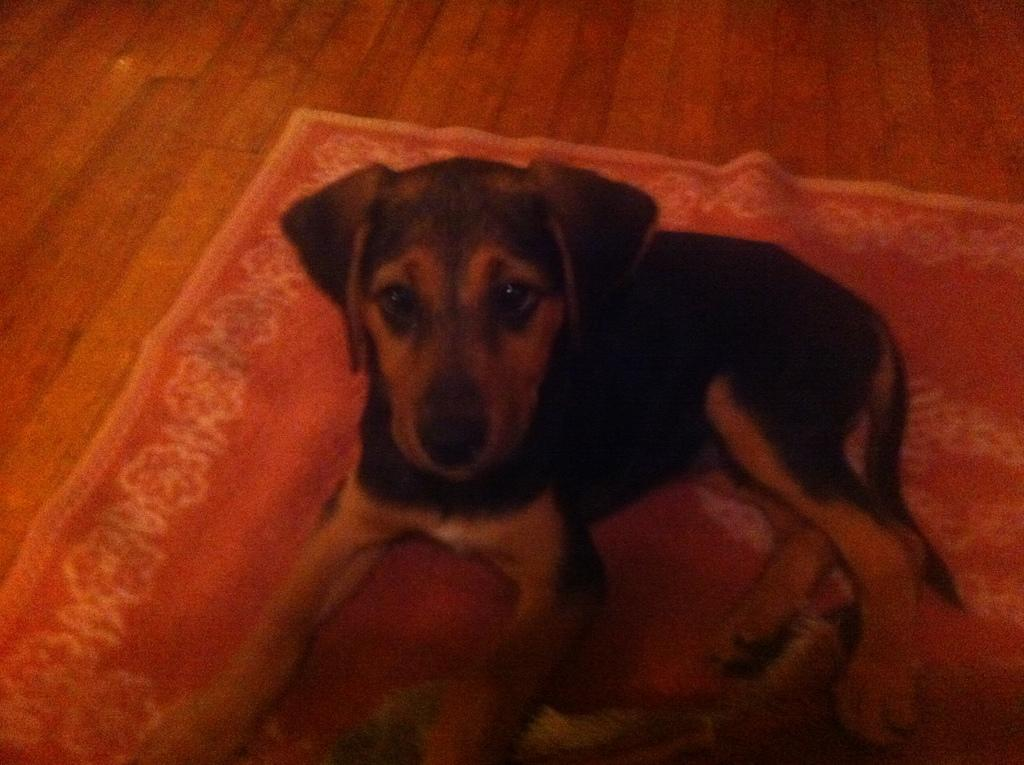What is the main subject in the center of the image? There is a dog in the center of the image. What is the dog sitting on? The dog is on a red color mat. What can be seen at the top of the image? The floor is visible at the top of the image. What type of cakes is the dog holding in its paws in the image? There are no cakes present in the image; the dog is sitting on a red color mat. 